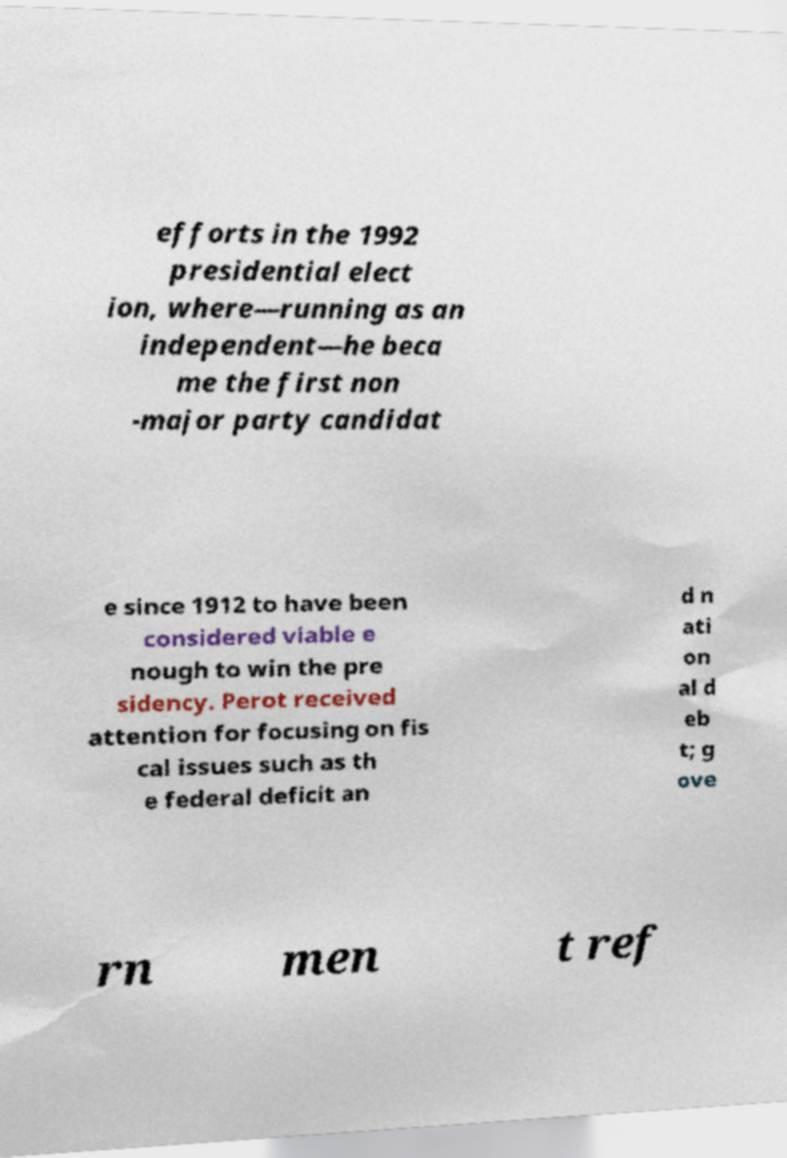Please read and relay the text visible in this image. What does it say? efforts in the 1992 presidential elect ion, where—running as an independent—he beca me the first non -major party candidat e since 1912 to have been considered viable e nough to win the pre sidency. Perot received attention for focusing on fis cal issues such as th e federal deficit an d n ati on al d eb t; g ove rn men t ref 